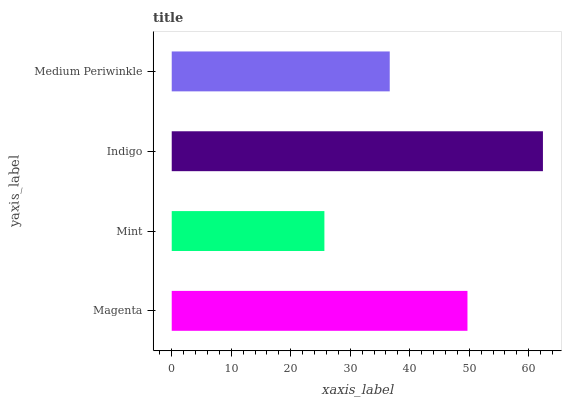Is Mint the minimum?
Answer yes or no. Yes. Is Indigo the maximum?
Answer yes or no. Yes. Is Indigo the minimum?
Answer yes or no. No. Is Mint the maximum?
Answer yes or no. No. Is Indigo greater than Mint?
Answer yes or no. Yes. Is Mint less than Indigo?
Answer yes or no. Yes. Is Mint greater than Indigo?
Answer yes or no. No. Is Indigo less than Mint?
Answer yes or no. No. Is Magenta the high median?
Answer yes or no. Yes. Is Medium Periwinkle the low median?
Answer yes or no. Yes. Is Mint the high median?
Answer yes or no. No. Is Magenta the low median?
Answer yes or no. No. 